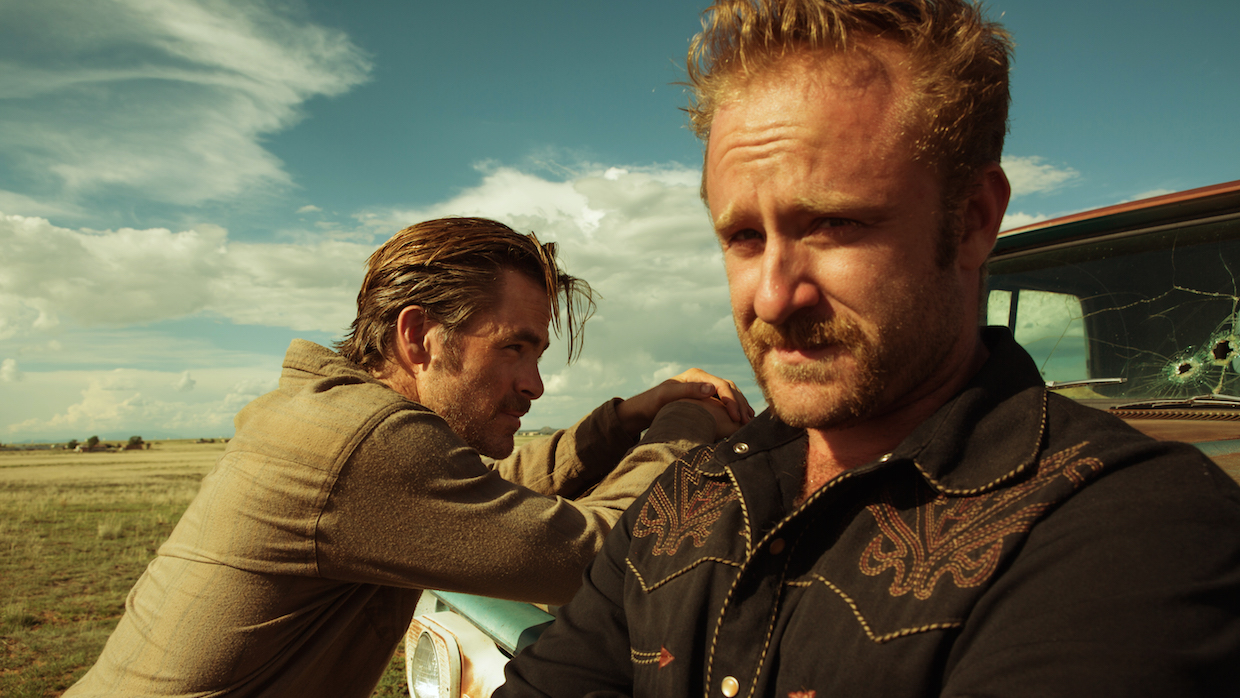Imagine how this scene could fit into a science fiction storyline. In a science fiction storyline, this scene could be set on a distant, desolate planet where resources are scarce, and survival is a daily challenge. The characters are rugged space explorers or rebels, evading a powerful, oppressive regime. The cracked windshield of their rugged space vehicle hints at a recent skirmish with robotic enforcers or hostile alien species. The expansive landscape represents the vast, untamed stretches of an alien world, fraught with unknown dangers. As they plan their next move, they might be on the verge of discovering a hidden rebel base or an ancient alien technology that could turn the tide in their favor. This storyline could explore themes of resistance, survival, and the quest for freedom in an unforgiving universe. Can you create a detailed backstory for these characters in a contemporary crime drama setting? In a contemporary crime drama setting, the man in the foreground, let’s call him Jake, is a former detective turned private investigator. His intense focus and rugged appearance reveal a man who has seen too much violence and is haunted by his past. His career took a sharp turn when his partner was killed in a botched drug raid, leading him to quit the force. He now operates on the fringes of legality, solving cases that the police have given up on. The man in the background, his relaxed stance contrasting with Jake’s intensity, is known as Tom. Tom was a petty criminal who Jake busted years ago. However, during his time in prison, Tom reformed and switched sides, becoming a valuable informant and eventually Jake’s trusted sidekick. They share a complicated relationship, bound by a mutual need for redemption and justice. The image captures them on a particularly intense case, involving a powerful crime syndicate that operates with impunity. The cracked windshield of their car is evidence of a recent attempt on their lives, reinforcing the high stakes of their current mission. Together, Jake’s relentless drive for justice and Tom’s street-smart resourcefulness make them a formidable team against the sprawling underworld they navigate daily. 